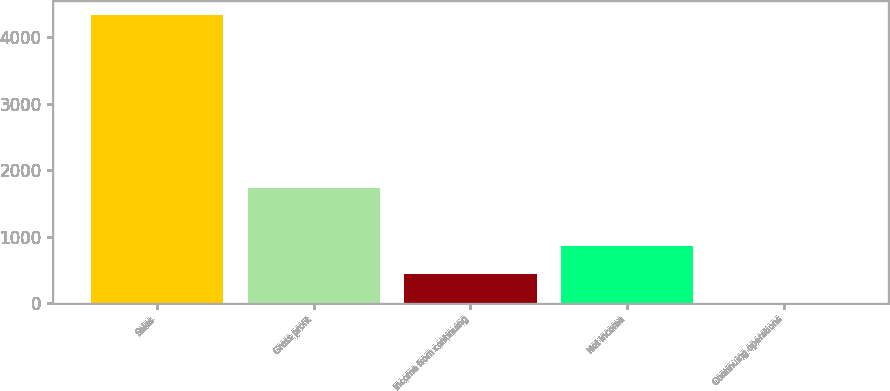<chart> <loc_0><loc_0><loc_500><loc_500><bar_chart><fcel>Sales<fcel>Gross profit<fcel>Income from continuing<fcel>Net income<fcel>Continuing operations<nl><fcel>4332.5<fcel>1733.94<fcel>434.64<fcel>867.74<fcel>1.54<nl></chart> 